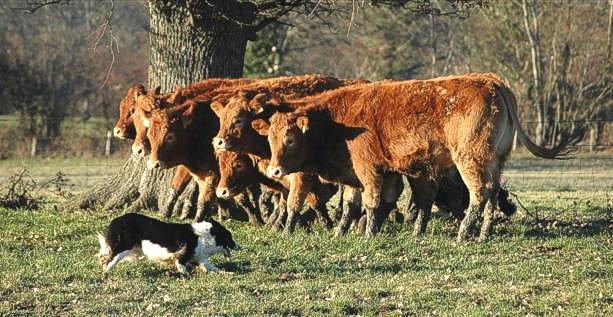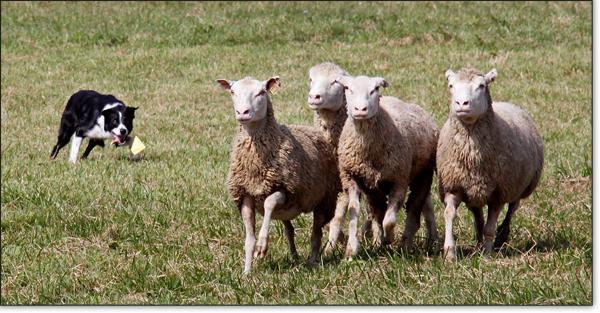The first image is the image on the left, the second image is the image on the right. Evaluate the accuracy of this statement regarding the images: "The dog in the image on the left is rounding up cattle.". Is it true? Answer yes or no. Yes. The first image is the image on the left, the second image is the image on the right. Examine the images to the left and right. Is the description "There are three sheeps and one dog in one of the images." accurate? Answer yes or no. No. 